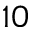<formula> <loc_0><loc_0><loc_500><loc_500>_ { 1 0 }</formula> 